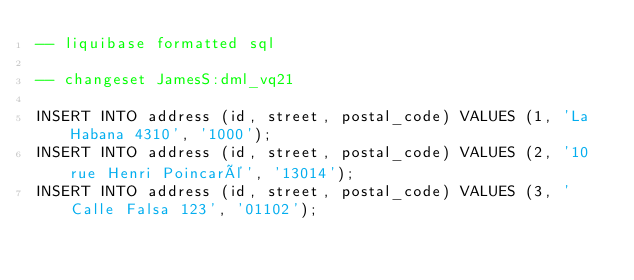Convert code to text. <code><loc_0><loc_0><loc_500><loc_500><_SQL_>-- liquibase formatted sql

-- changeset JamesS:dml_vq21

INSERT INTO address (id, street, postal_code) VALUES (1, 'La Habana 4310', '1000');
INSERT INTO address (id, street, postal_code) VALUES (2, '10 rue Henri Poincaré', '13014');
INSERT INTO address (id, street, postal_code) VALUES (3, 'Calle Falsa 123', '01102');
</code> 